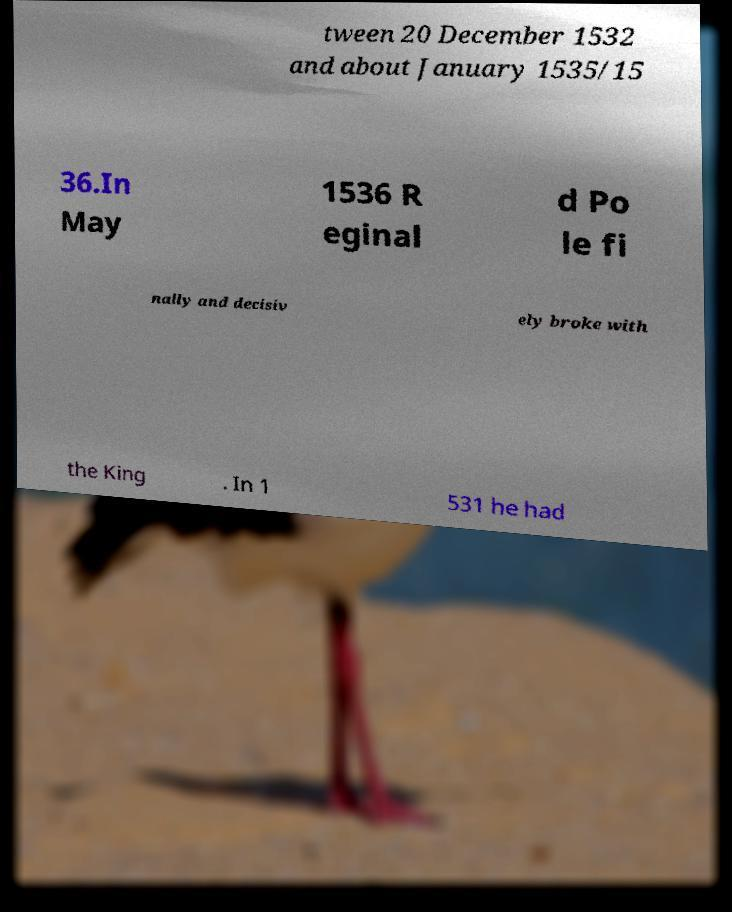Can you accurately transcribe the text from the provided image for me? tween 20 December 1532 and about January 1535/15 36.In May 1536 R eginal d Po le fi nally and decisiv ely broke with the King . In 1 531 he had 